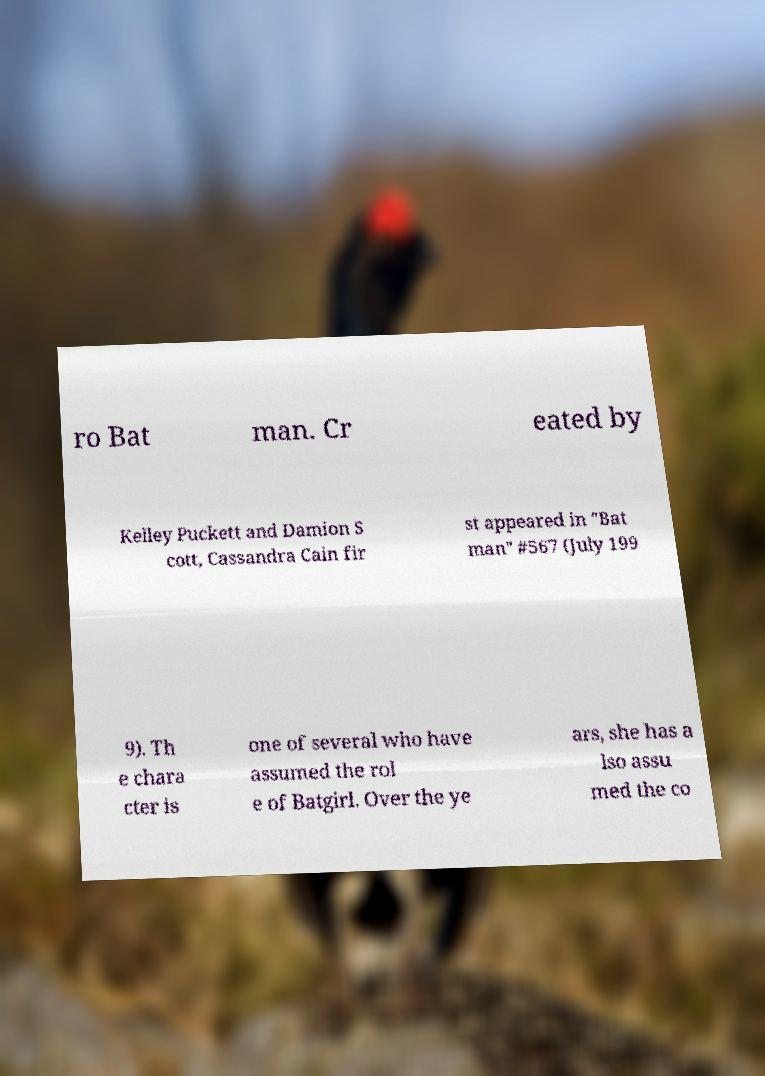Could you assist in decoding the text presented in this image and type it out clearly? ro Bat man. Cr eated by Kelley Puckett and Damion S cott, Cassandra Cain fir st appeared in "Bat man" #567 (July 199 9). Th e chara cter is one of several who have assumed the rol e of Batgirl. Over the ye ars, she has a lso assu med the co 